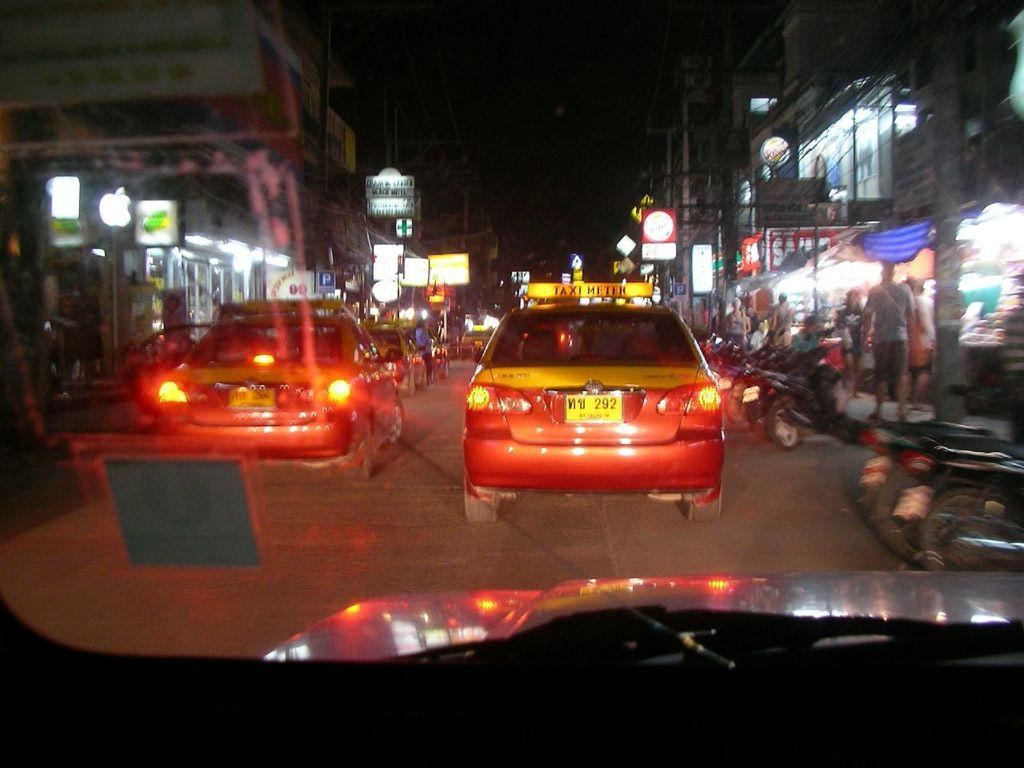<image>
Offer a succinct explanation of the picture presented. a car with the numbers 292 at the back of it 